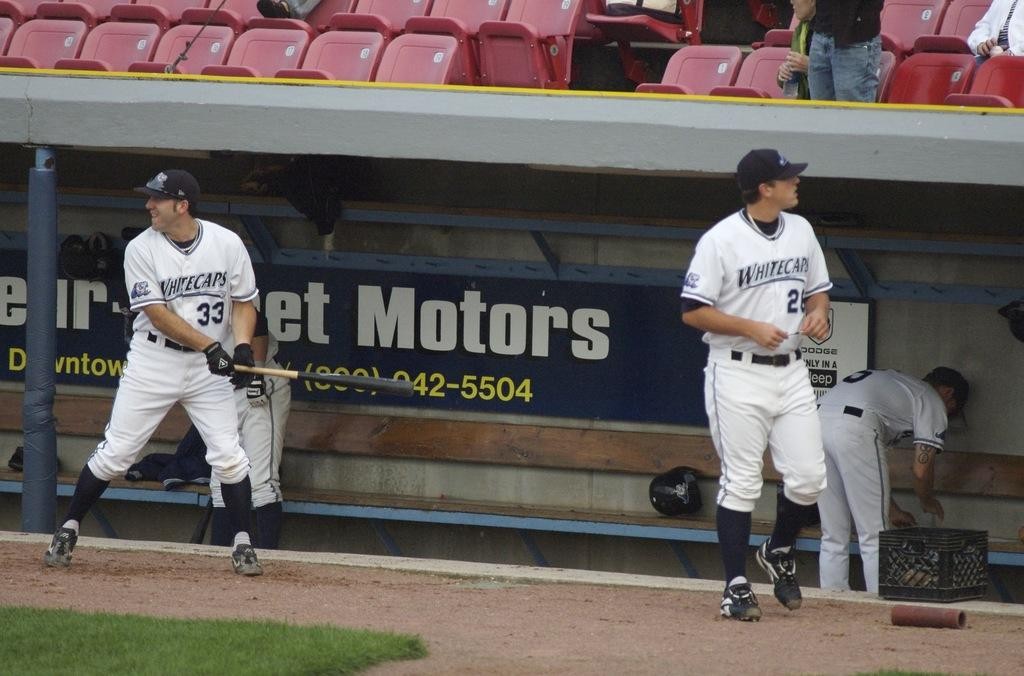Provide a one-sentence caption for the provided image. Several players from the Whitecaps baseball team are near their dugout. 